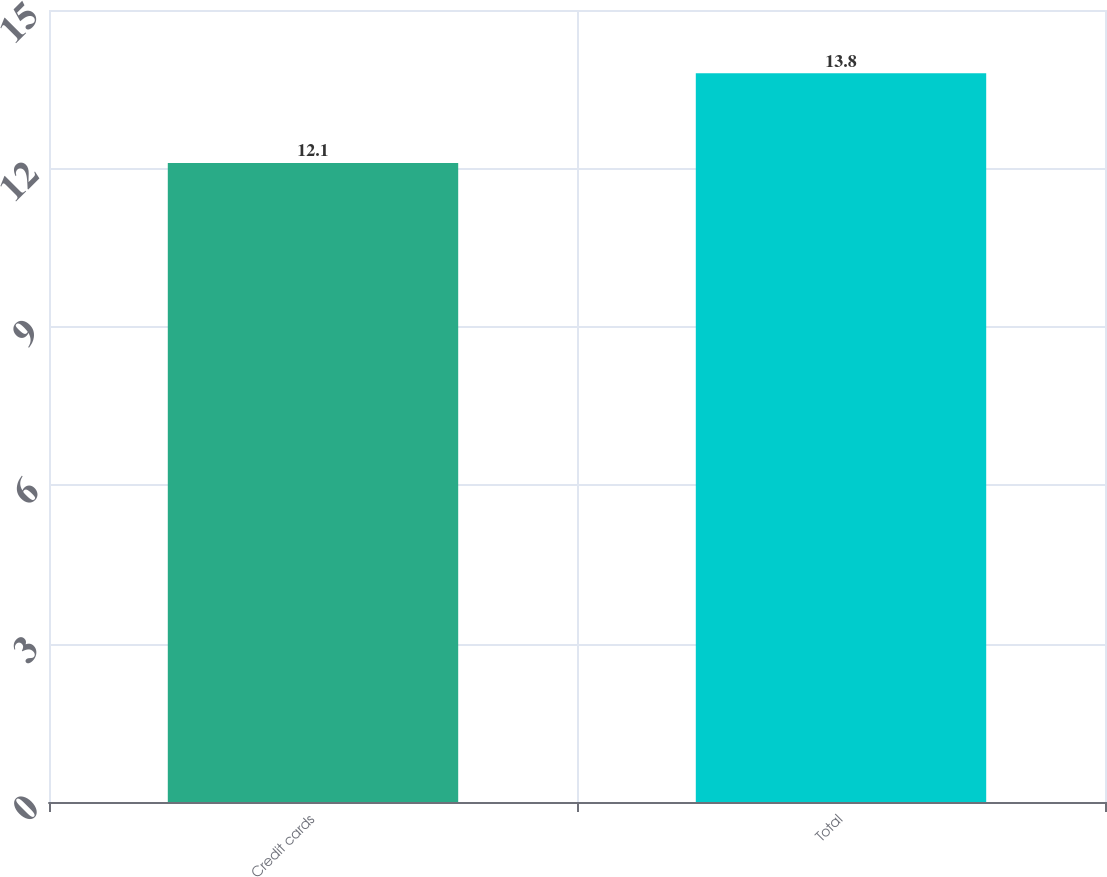Convert chart. <chart><loc_0><loc_0><loc_500><loc_500><bar_chart><fcel>Credit cards<fcel>Total<nl><fcel>12.1<fcel>13.8<nl></chart> 